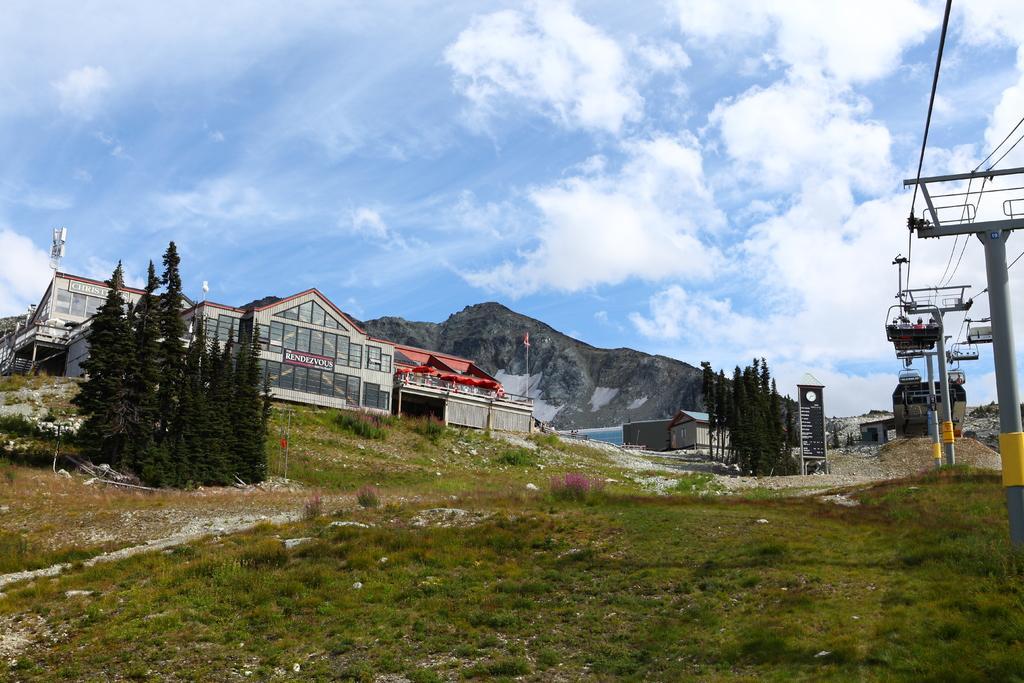Please provide a concise description of this image. This image is clicked outside. At the bottom, there is green grass on the ground. On the right, we can see the poles along with wires. It looks like a ropeway. In the front, there is a building. In the background, there is a mountain. In the middle, there are trees. At the top, there are clouds in the sky. 